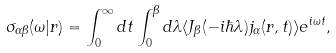<formula> <loc_0><loc_0><loc_500><loc_500>\sigma _ { \alpha \beta } ( \omega | { r } ) = \int _ { 0 } ^ { \infty } d t \int _ { 0 } ^ { \beta } d \lambda \langle J _ { \beta } ( - i \hbar { \lambda } ) j _ { \alpha } ( { r } , t ) \rangle e ^ { i \omega t } ,</formula> 